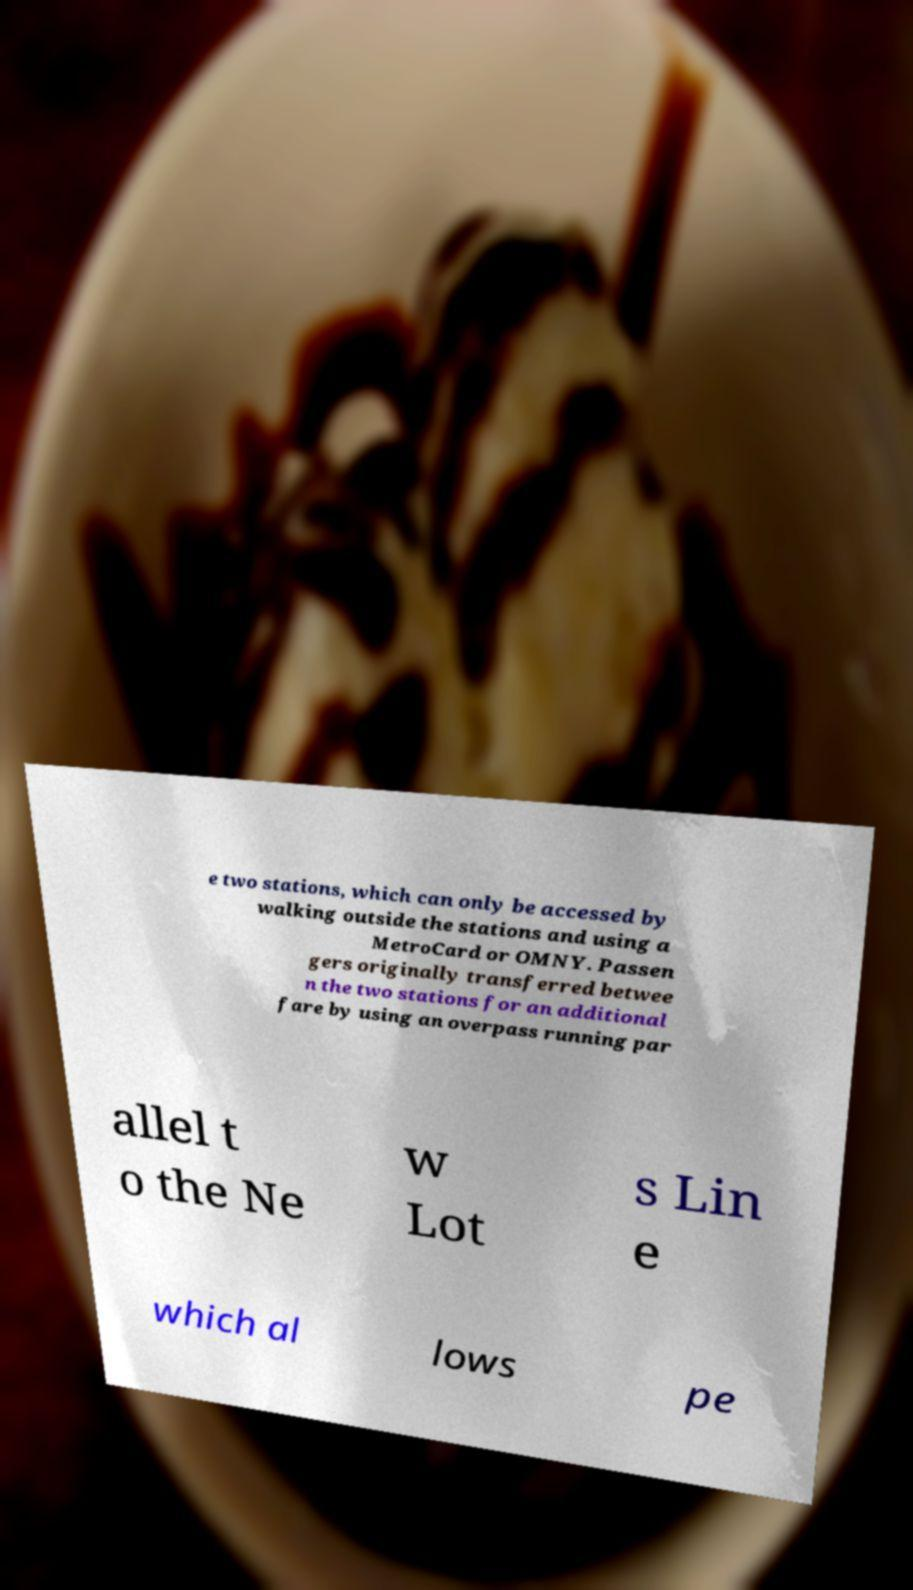Can you read and provide the text displayed in the image?This photo seems to have some interesting text. Can you extract and type it out for me? e two stations, which can only be accessed by walking outside the stations and using a MetroCard or OMNY. Passen gers originally transferred betwee n the two stations for an additional fare by using an overpass running par allel t o the Ne w Lot s Lin e which al lows pe 